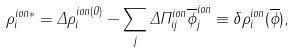<formula> <loc_0><loc_0><loc_500><loc_500>\rho _ { i } ^ { i o n * } = \Delta \rho _ { i } ^ { i o n ( 0 ) } - \sum _ { j } \Delta \Pi _ { i j } ^ { i o n } \overline { \phi } _ { j } ^ { i o n } \equiv \delta \rho _ { i } ^ { i o n } ( \overline { \phi } ) ,</formula> 